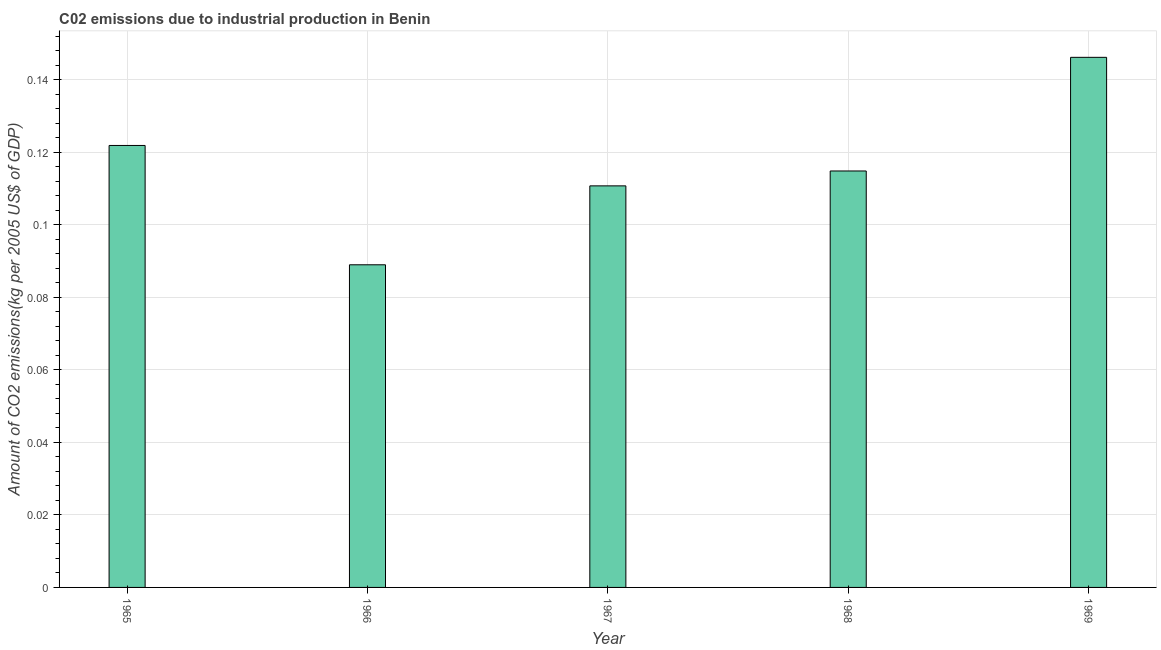What is the title of the graph?
Your response must be concise. C02 emissions due to industrial production in Benin. What is the label or title of the Y-axis?
Your response must be concise. Amount of CO2 emissions(kg per 2005 US$ of GDP). What is the amount of co2 emissions in 1966?
Ensure brevity in your answer.  0.09. Across all years, what is the maximum amount of co2 emissions?
Keep it short and to the point. 0.15. Across all years, what is the minimum amount of co2 emissions?
Your response must be concise. 0.09. In which year was the amount of co2 emissions maximum?
Your answer should be compact. 1969. In which year was the amount of co2 emissions minimum?
Ensure brevity in your answer.  1966. What is the sum of the amount of co2 emissions?
Give a very brief answer. 0.58. What is the difference between the amount of co2 emissions in 1967 and 1969?
Make the answer very short. -0.04. What is the average amount of co2 emissions per year?
Offer a terse response. 0.12. What is the median amount of co2 emissions?
Offer a very short reply. 0.11. In how many years, is the amount of co2 emissions greater than 0.052 kg per 2005 US$ of GDP?
Ensure brevity in your answer.  5. Do a majority of the years between 1965 and 1968 (inclusive) have amount of co2 emissions greater than 0.112 kg per 2005 US$ of GDP?
Offer a terse response. No. What is the ratio of the amount of co2 emissions in 1968 to that in 1969?
Offer a very short reply. 0.79. Is the amount of co2 emissions in 1965 less than that in 1968?
Ensure brevity in your answer.  No. What is the difference between the highest and the second highest amount of co2 emissions?
Provide a short and direct response. 0.02. What is the difference between the highest and the lowest amount of co2 emissions?
Offer a very short reply. 0.06. In how many years, is the amount of co2 emissions greater than the average amount of co2 emissions taken over all years?
Provide a succinct answer. 2. How many years are there in the graph?
Your response must be concise. 5. What is the difference between two consecutive major ticks on the Y-axis?
Your response must be concise. 0.02. What is the Amount of CO2 emissions(kg per 2005 US$ of GDP) in 1965?
Your answer should be very brief. 0.12. What is the Amount of CO2 emissions(kg per 2005 US$ of GDP) in 1966?
Your answer should be compact. 0.09. What is the Amount of CO2 emissions(kg per 2005 US$ of GDP) in 1967?
Give a very brief answer. 0.11. What is the Amount of CO2 emissions(kg per 2005 US$ of GDP) of 1968?
Make the answer very short. 0.11. What is the Amount of CO2 emissions(kg per 2005 US$ of GDP) of 1969?
Offer a very short reply. 0.15. What is the difference between the Amount of CO2 emissions(kg per 2005 US$ of GDP) in 1965 and 1966?
Make the answer very short. 0.03. What is the difference between the Amount of CO2 emissions(kg per 2005 US$ of GDP) in 1965 and 1967?
Keep it short and to the point. 0.01. What is the difference between the Amount of CO2 emissions(kg per 2005 US$ of GDP) in 1965 and 1968?
Make the answer very short. 0.01. What is the difference between the Amount of CO2 emissions(kg per 2005 US$ of GDP) in 1965 and 1969?
Offer a very short reply. -0.02. What is the difference between the Amount of CO2 emissions(kg per 2005 US$ of GDP) in 1966 and 1967?
Your answer should be compact. -0.02. What is the difference between the Amount of CO2 emissions(kg per 2005 US$ of GDP) in 1966 and 1968?
Your response must be concise. -0.03. What is the difference between the Amount of CO2 emissions(kg per 2005 US$ of GDP) in 1966 and 1969?
Offer a very short reply. -0.06. What is the difference between the Amount of CO2 emissions(kg per 2005 US$ of GDP) in 1967 and 1968?
Your answer should be compact. -0. What is the difference between the Amount of CO2 emissions(kg per 2005 US$ of GDP) in 1967 and 1969?
Offer a terse response. -0.04. What is the difference between the Amount of CO2 emissions(kg per 2005 US$ of GDP) in 1968 and 1969?
Provide a succinct answer. -0.03. What is the ratio of the Amount of CO2 emissions(kg per 2005 US$ of GDP) in 1965 to that in 1966?
Offer a very short reply. 1.37. What is the ratio of the Amount of CO2 emissions(kg per 2005 US$ of GDP) in 1965 to that in 1967?
Your response must be concise. 1.1. What is the ratio of the Amount of CO2 emissions(kg per 2005 US$ of GDP) in 1965 to that in 1968?
Your answer should be very brief. 1.06. What is the ratio of the Amount of CO2 emissions(kg per 2005 US$ of GDP) in 1965 to that in 1969?
Your response must be concise. 0.83. What is the ratio of the Amount of CO2 emissions(kg per 2005 US$ of GDP) in 1966 to that in 1967?
Give a very brief answer. 0.8. What is the ratio of the Amount of CO2 emissions(kg per 2005 US$ of GDP) in 1966 to that in 1968?
Keep it short and to the point. 0.78. What is the ratio of the Amount of CO2 emissions(kg per 2005 US$ of GDP) in 1966 to that in 1969?
Your response must be concise. 0.61. What is the ratio of the Amount of CO2 emissions(kg per 2005 US$ of GDP) in 1967 to that in 1969?
Give a very brief answer. 0.76. What is the ratio of the Amount of CO2 emissions(kg per 2005 US$ of GDP) in 1968 to that in 1969?
Ensure brevity in your answer.  0.79. 